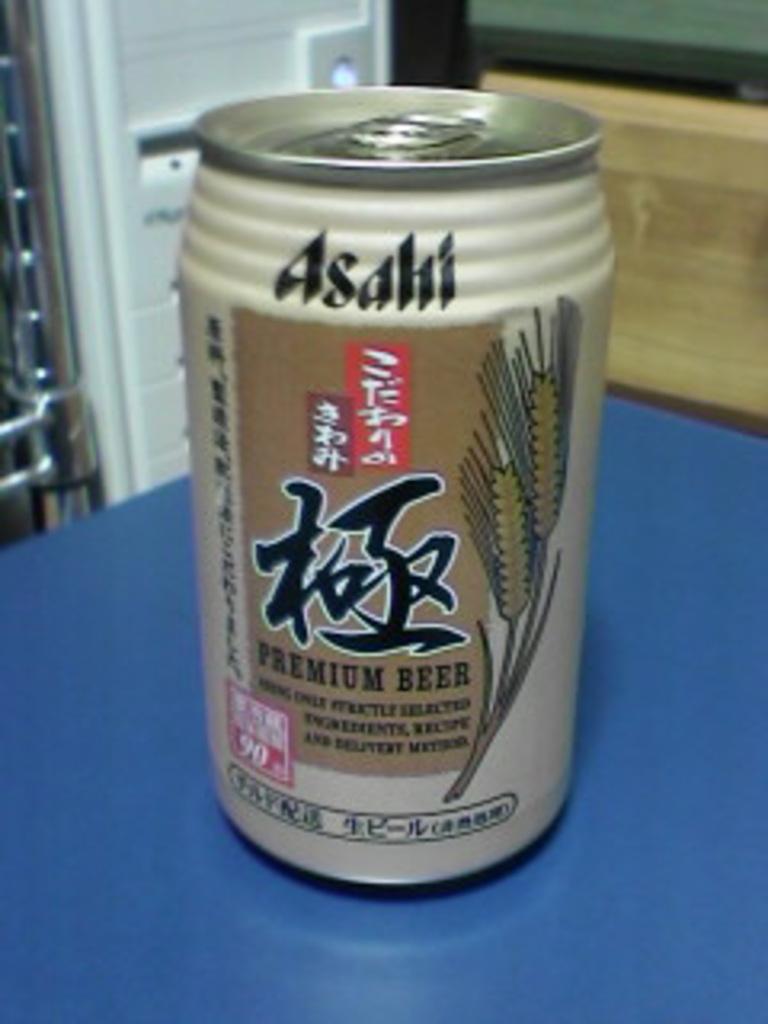What type of beer is this?
Your response must be concise. Asahi. 